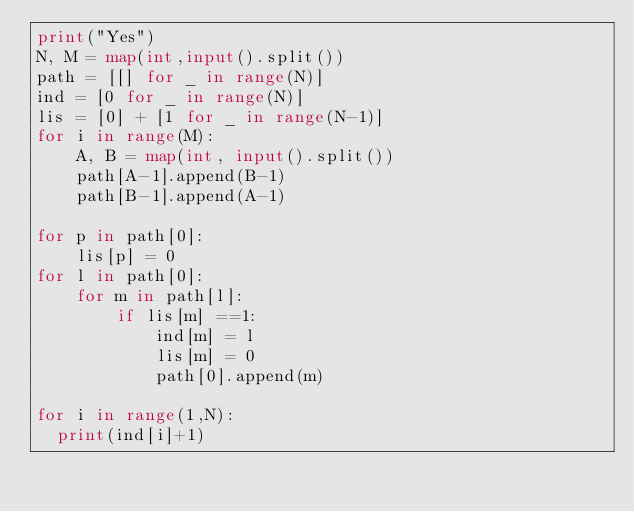<code> <loc_0><loc_0><loc_500><loc_500><_Python_>print("Yes")
N, M = map(int,input().split())
path = [[] for _ in range(N)]
ind = [0 for _ in range(N)]
lis = [0] + [1 for _ in range(N-1)]
for i in range(M):
    A, B = map(int, input().split())
    path[A-1].append(B-1)
    path[B-1].append(A-1)

for p in path[0]:
    lis[p] = 0
for l in path[0]:
    for m in path[l]:
        if lis[m] ==1:
            ind[m] = l
            lis[m] = 0
            path[0].append(m)

for i in range(1,N):
  print(ind[i]+1)
            
            
           </code> 